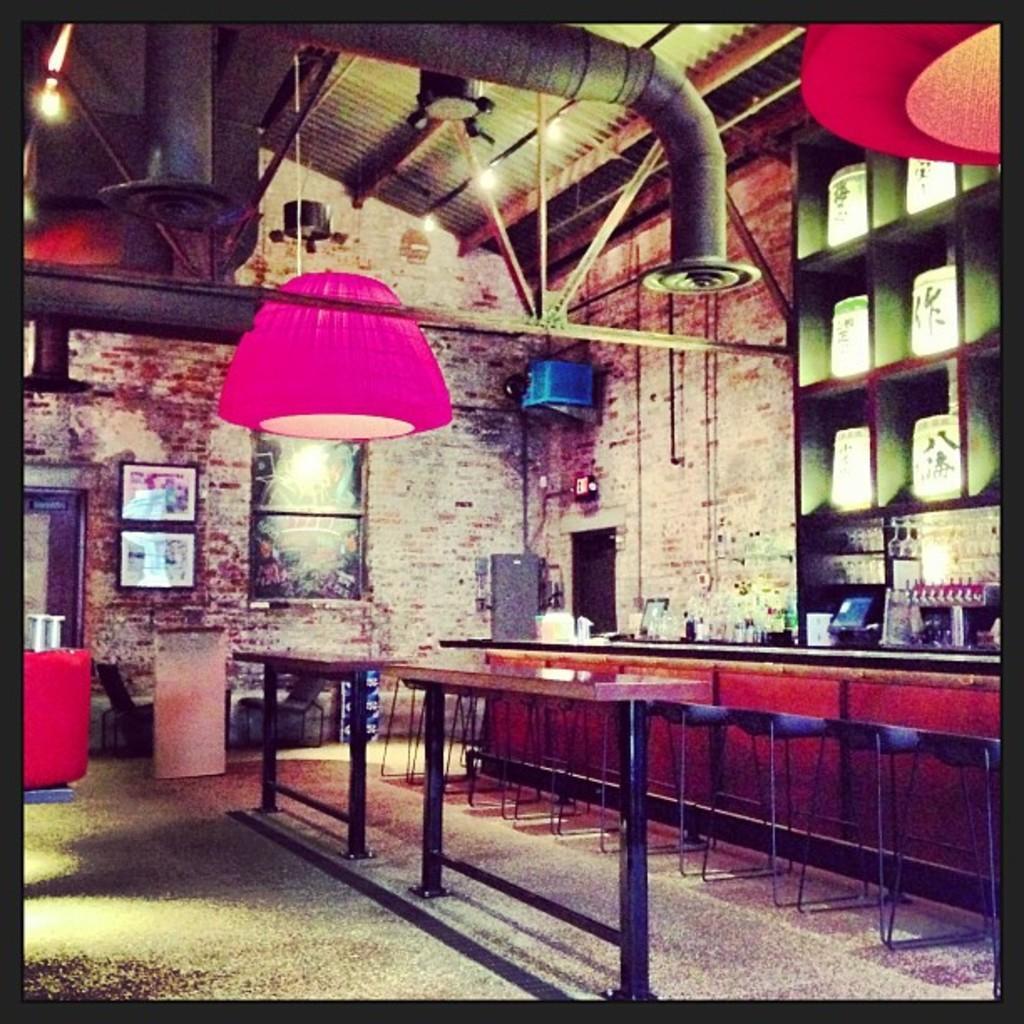In one or two sentences, can you explain what this image depicts? It looks like a room, on the right side there are chairs, in the middle there are dining tables. 